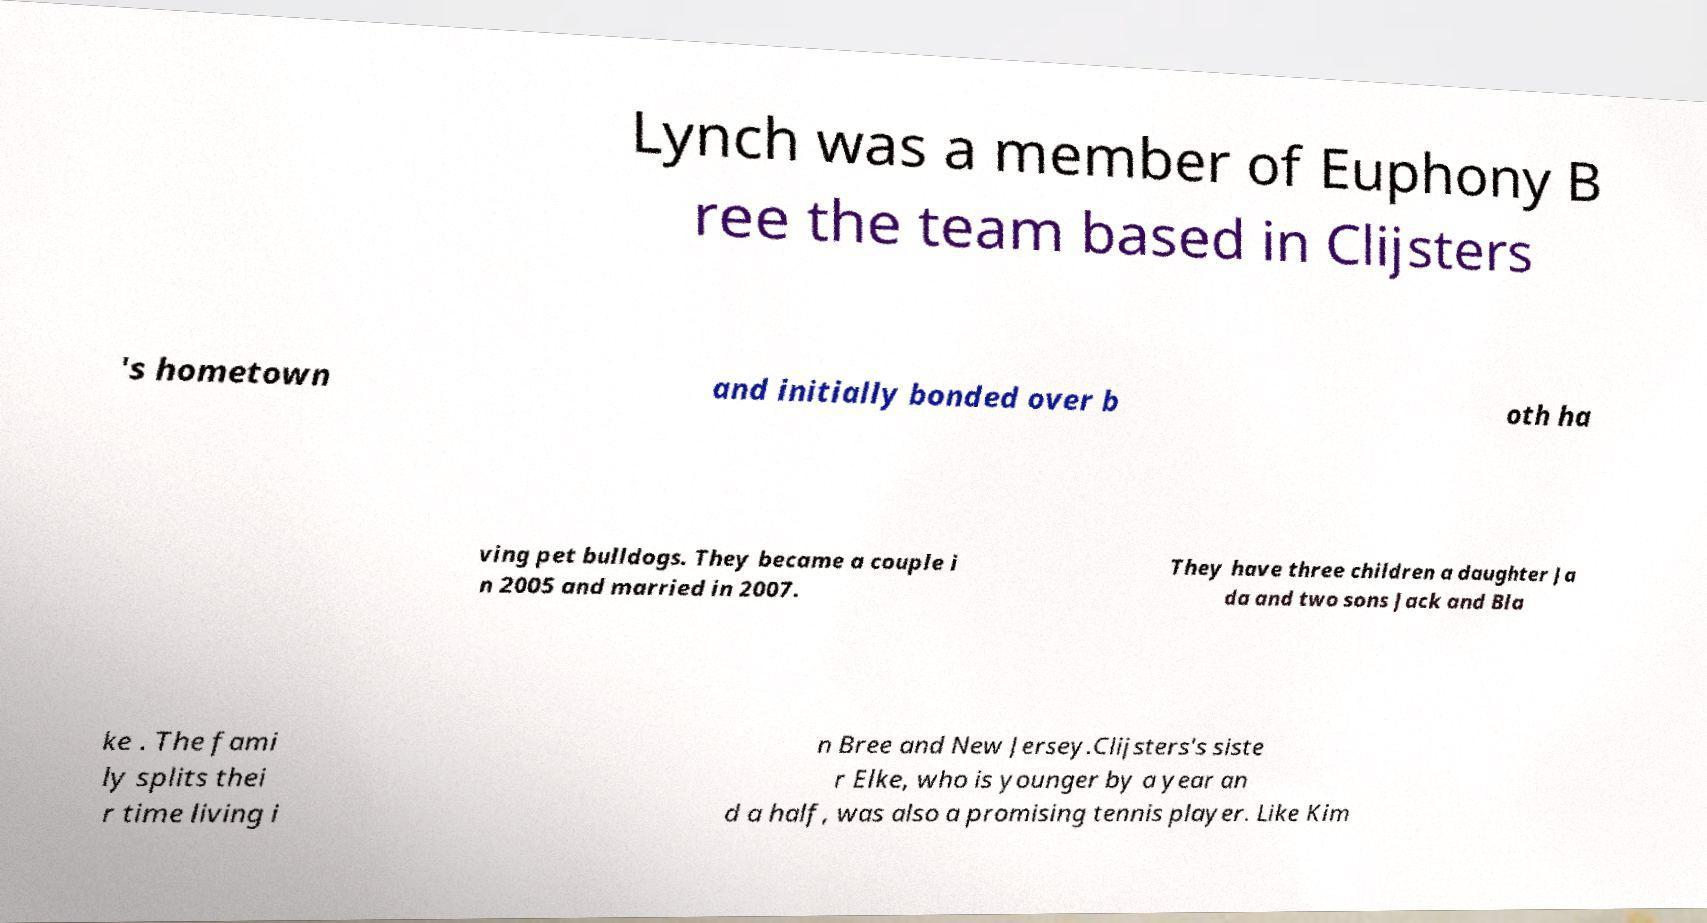Please read and relay the text visible in this image. What does it say? Lynch was a member of Euphony B ree the team based in Clijsters 's hometown and initially bonded over b oth ha ving pet bulldogs. They became a couple i n 2005 and married in 2007. They have three children a daughter Ja da and two sons Jack and Bla ke . The fami ly splits thei r time living i n Bree and New Jersey.Clijsters's siste r Elke, who is younger by a year an d a half, was also a promising tennis player. Like Kim 